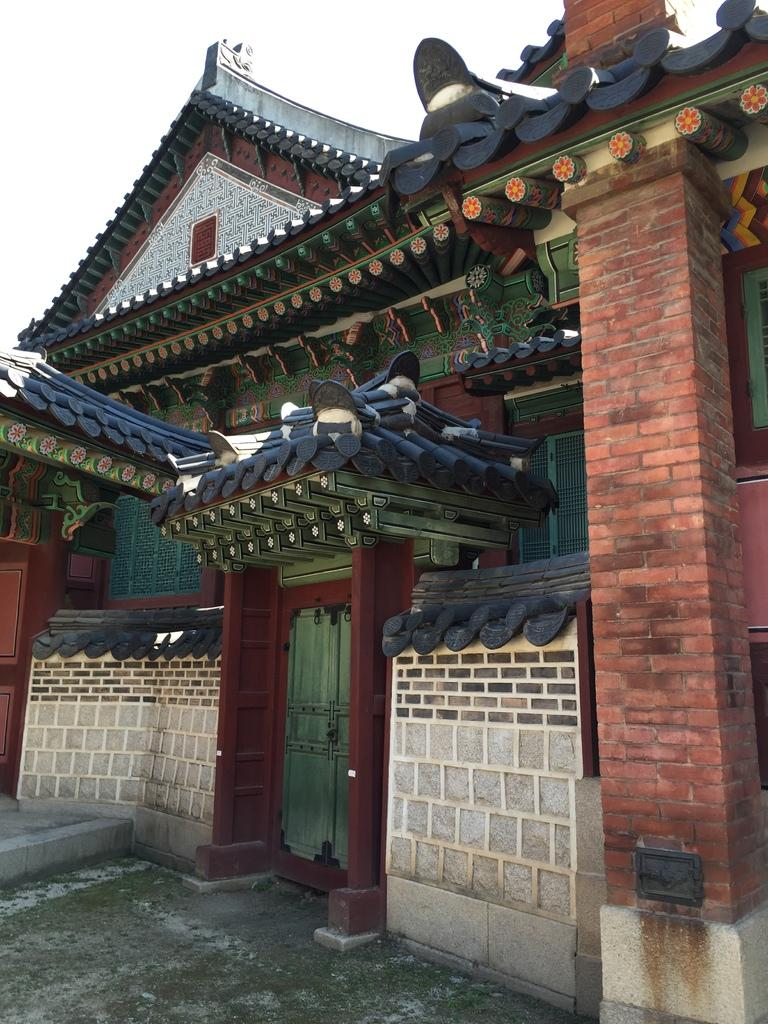What type of structure is present in the image? There is a building in the image. What type of barrier is visible in the image? There is a fence in the image. What feature of the building is mentioned in the facts? There are doors in the image. What part of the natural environment is visible in the image? The sky is visible in the background of the image. What type of position does the drain hold in the image? There is no drain present in the image. What type of agreement is being made in the image? There is no agreement being made in the image. 